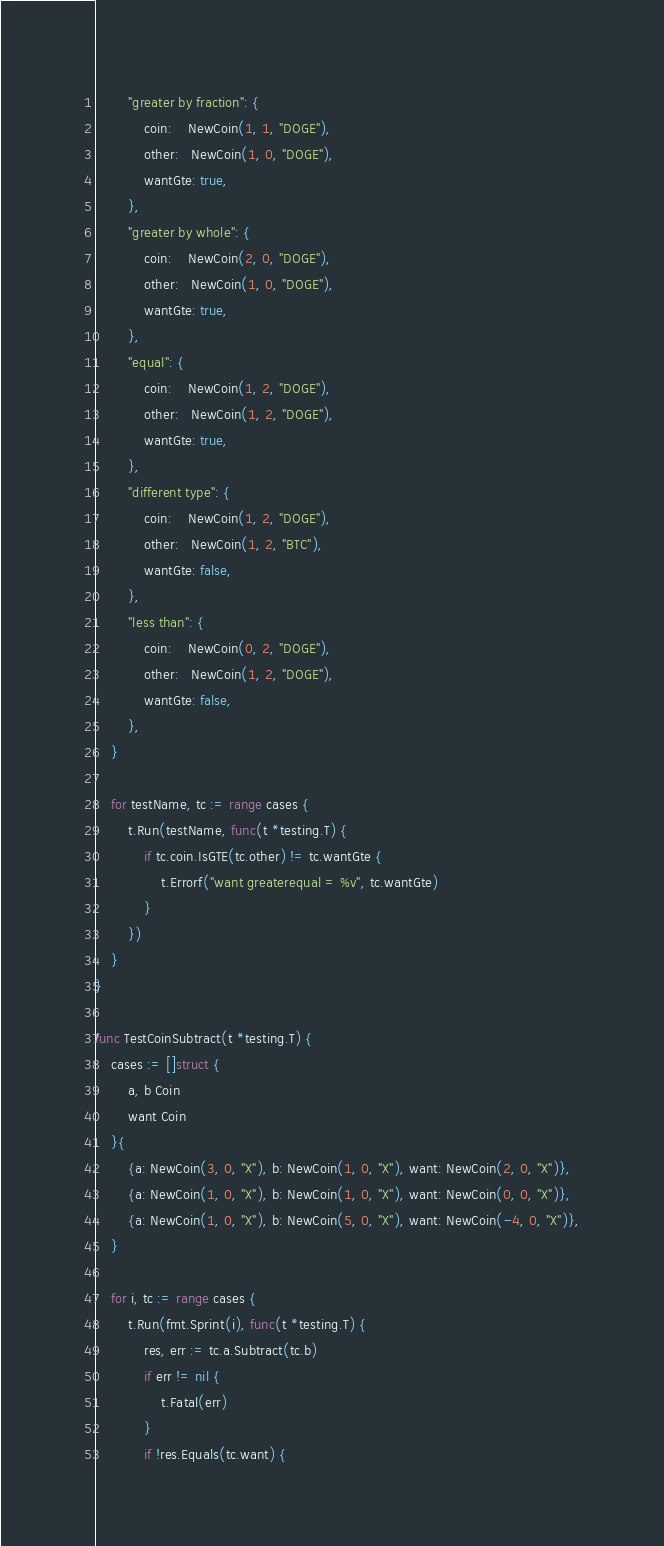<code> <loc_0><loc_0><loc_500><loc_500><_Go_>		"greater by fraction": {
			coin:    NewCoin(1, 1, "DOGE"),
			other:   NewCoin(1, 0, "DOGE"),
			wantGte: true,
		},
		"greater by whole": {
			coin:    NewCoin(2, 0, "DOGE"),
			other:   NewCoin(1, 0, "DOGE"),
			wantGte: true,
		},
		"equal": {
			coin:    NewCoin(1, 2, "DOGE"),
			other:   NewCoin(1, 2, "DOGE"),
			wantGte: true,
		},
		"different type": {
			coin:    NewCoin(1, 2, "DOGE"),
			other:   NewCoin(1, 2, "BTC"),
			wantGte: false,
		},
		"less than": {
			coin:    NewCoin(0, 2, "DOGE"),
			other:   NewCoin(1, 2, "DOGE"),
			wantGte: false,
		},
	}

	for testName, tc := range cases {
		t.Run(testName, func(t *testing.T) {
			if tc.coin.IsGTE(tc.other) != tc.wantGte {
				t.Errorf("want greaterequal = %v", tc.wantGte)
			}
		})
	}
}

func TestCoinSubtract(t *testing.T) {
	cases := []struct {
		a, b Coin
		want Coin
	}{
		{a: NewCoin(3, 0, "X"), b: NewCoin(1, 0, "X"), want: NewCoin(2, 0, "X")},
		{a: NewCoin(1, 0, "X"), b: NewCoin(1, 0, "X"), want: NewCoin(0, 0, "X")},
		{a: NewCoin(1, 0, "X"), b: NewCoin(5, 0, "X"), want: NewCoin(-4, 0, "X")},
	}

	for i, tc := range cases {
		t.Run(fmt.Sprint(i), func(t *testing.T) {
			res, err := tc.a.Subtract(tc.b)
			if err != nil {
				t.Fatal(err)
			}
			if !res.Equals(tc.want) {</code> 